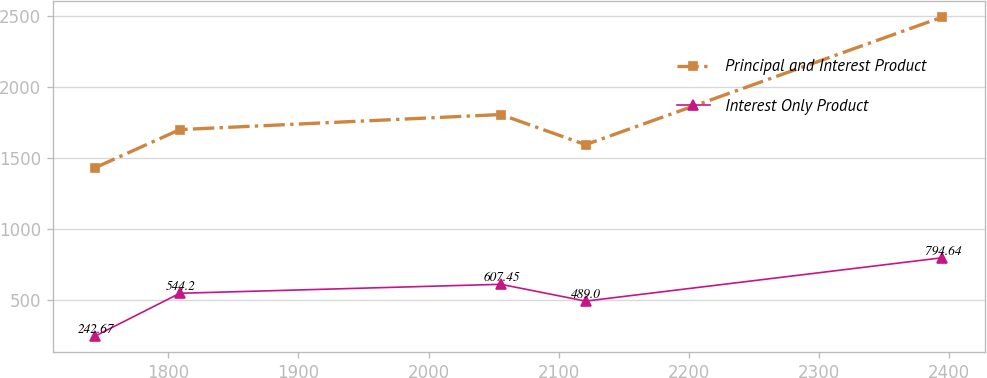Convert chart. <chart><loc_0><loc_0><loc_500><loc_500><line_chart><ecel><fcel>Principal and Interest Product<fcel>Interest Only Product<nl><fcel>1743.64<fcel>1429.12<fcel>242.67<nl><fcel>1808.78<fcel>1697.68<fcel>544.2<nl><fcel>2055.57<fcel>1803.87<fcel>607.45<nl><fcel>2120.71<fcel>1591.49<fcel>489<nl><fcel>2395.06<fcel>2491.02<fcel>794.64<nl></chart> 